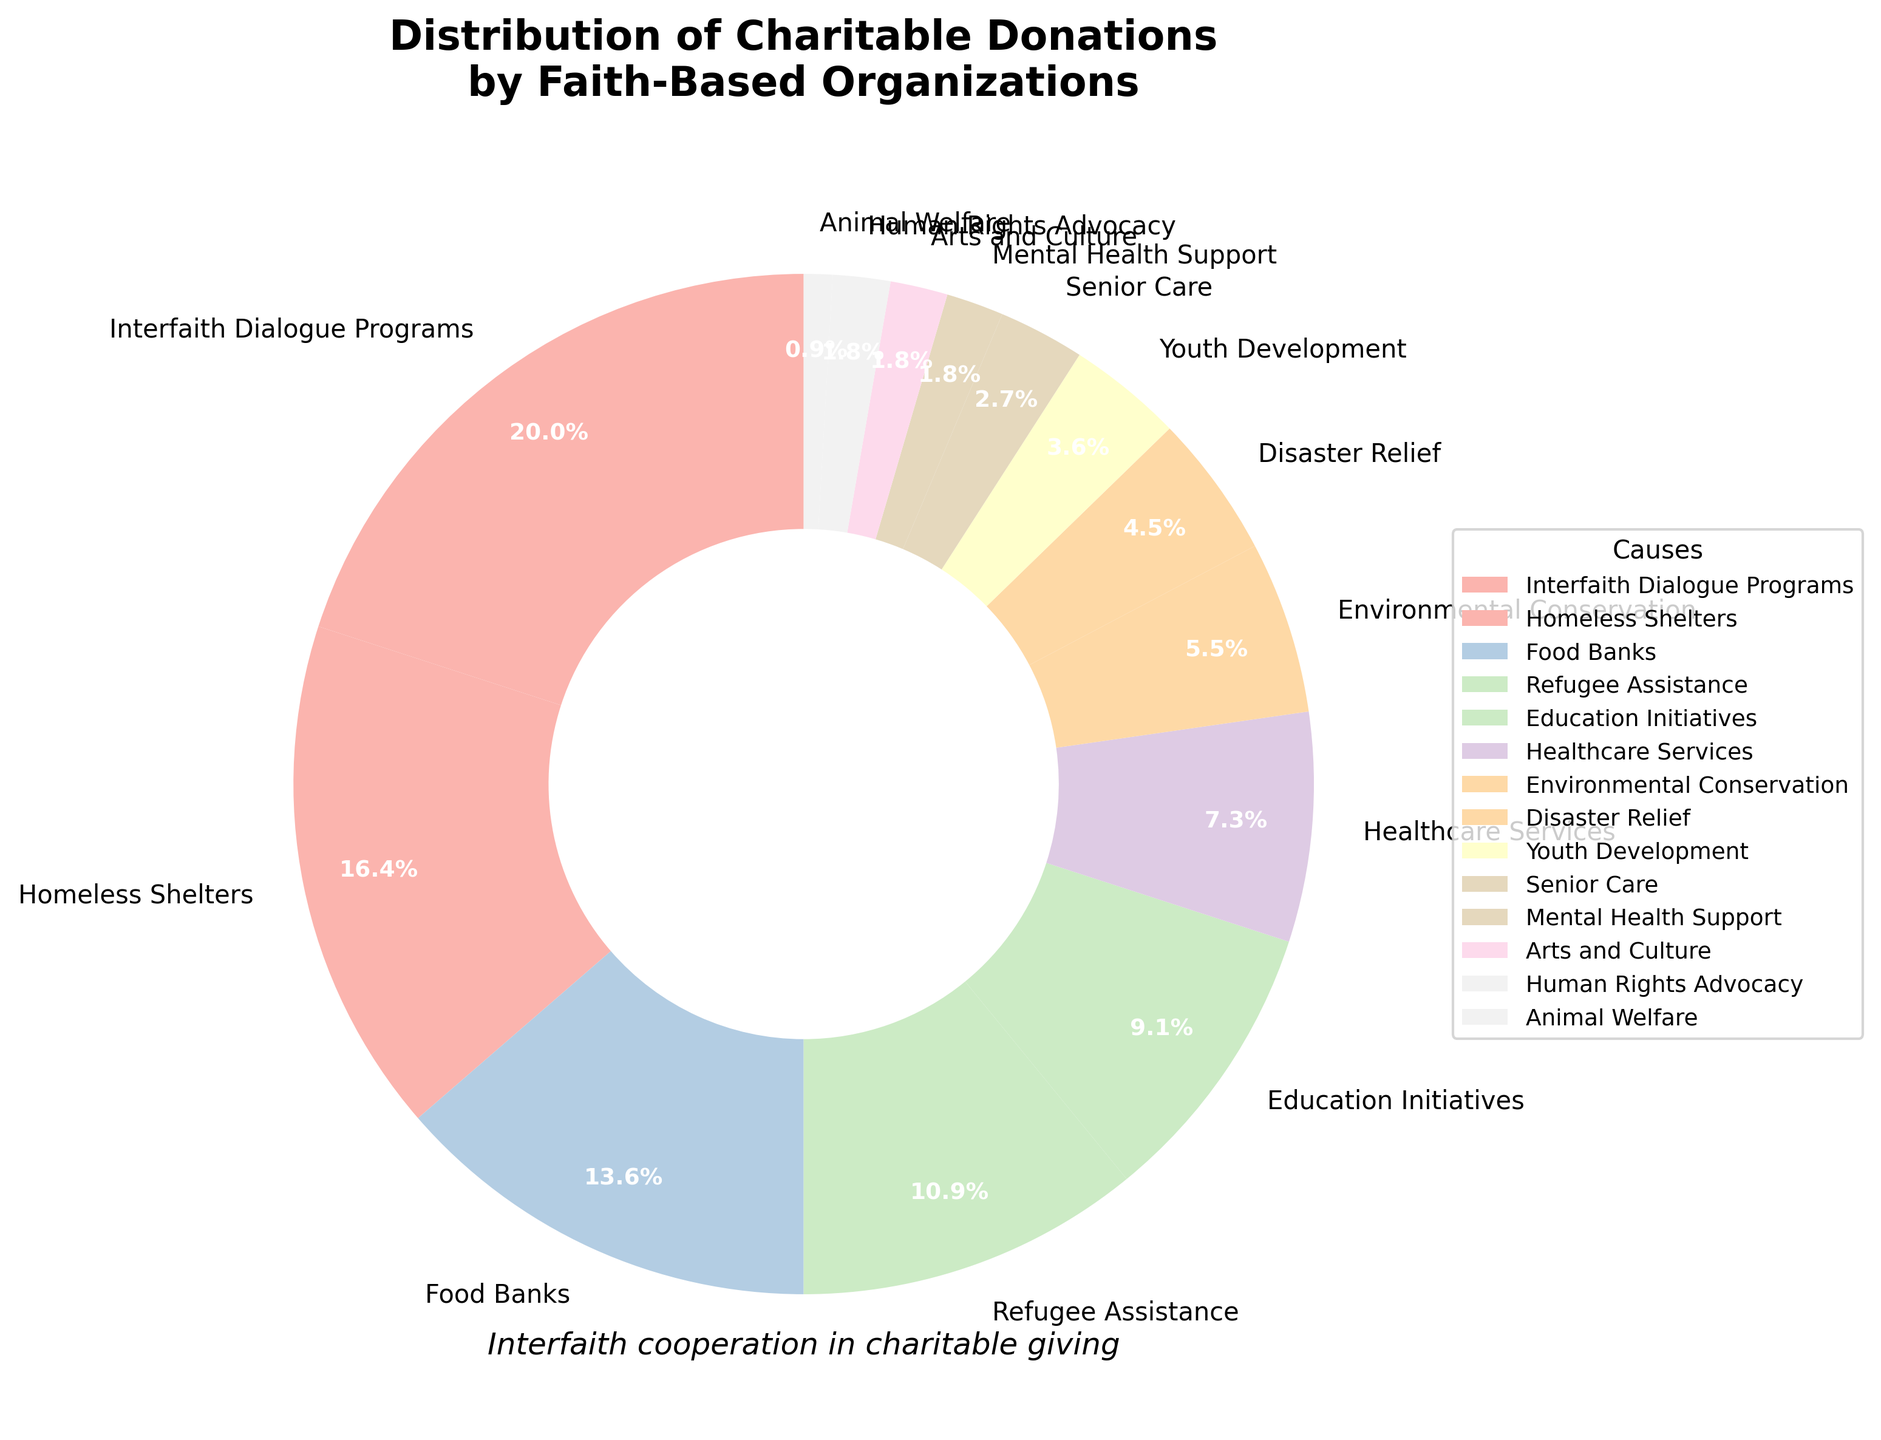What percentage of donations go to education initiatives? In the pie chart, the slice labeled "Education Initiatives" represents 10% of the total donations.
Answer: 10% Which cause receives the highest percentage of donations? The largest slice of the pie chart represents "Interfaith Dialogue Programs," which has the highest percentage of donations at 22%.
Answer: Interfaith Dialogue Programs How much more do faith-based organizations donate to food banks than to healthcare services? The percentage of donations to food banks is 15%, while healthcare services receive 8%. The difference is 15% - 8% = 7%.
Answer: 7% What is the combined percentage of donations going to causes related to basic needs (homeless shelters, food banks, refugee assistance)? Summing the percentages for homeless shelters (18%), food banks (15%), and refugee assistance (12%) gives 18% + 15% + 12% = 45%.
Answer: 45% Are there more donations allocated to arts and culture or human rights advocacy? Both "Arts and Culture" and "Human Rights Advocacy" have a slice representing 2% of the donations each, indicating that they receive equal amounts.
Answer: Equal What is the median percentage value of the causes listed? To find the median, list all the percentages in ascending order: 1%, 2%, 2%, 2%, 3%, 4%, 5%, 6%, 8%, 10%, 12%, 15%, 18%, 22%. Since there are 14 values, the median is the average of the 7th and 8th values, (5% + 6%) / 2 = 5.5%.
Answer: 5.5% What percentage of donations are allocated to youth development and senior care combined? Adding the percentages for youth development (4%) and senior care (3%) gives 4% + 3% = 7%.
Answer: 7% What is the difference in the percentage of donations between environmental conservation and arts and culture? Environmental conservation has 6% while arts and culture have 2%, so the difference is 6% - 2% = 4%.
Answer: 4% Which gets more funding: disaster relief or mental health support? Disaster relief receives 5% of donations, while mental health support receives 2%, meaning disaster relief gets more funding.
Answer: Disaster Relief If faith-based organizations plan to increase their donation to refugee assistance by 5%, what will the new percentage be? Refugee assistance currently receives 12%. Adding 5% will be 12% + 5% = 17%.
Answer: 17% 